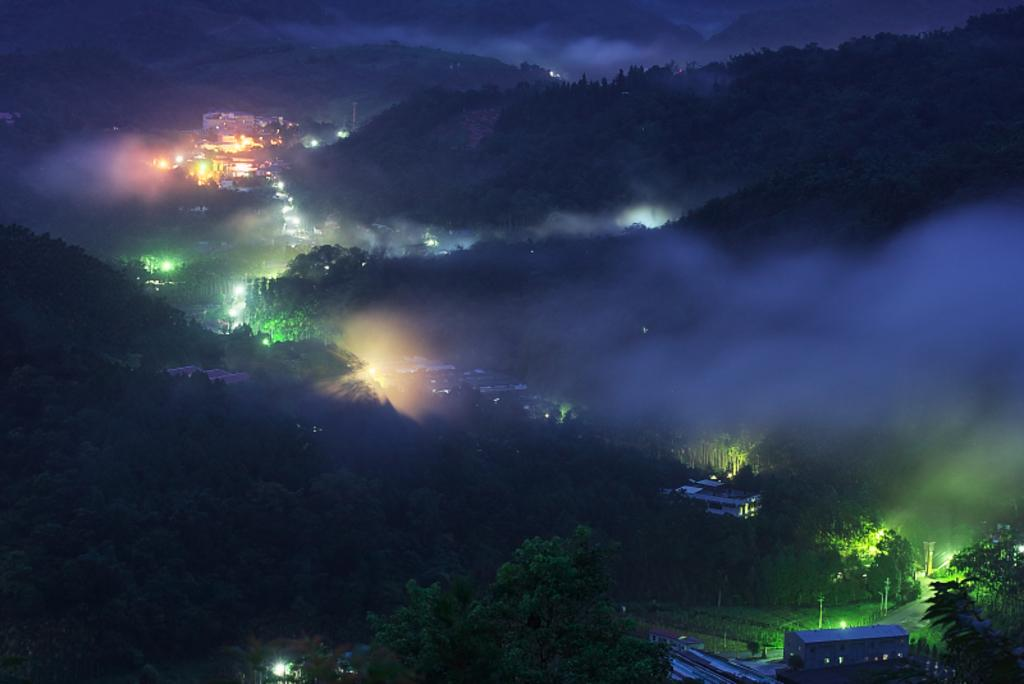What type of natural feature can be seen in the image? There is a group of trees in the image. What type of man-made structures are present in the image? There are buildings in the image. What type of vertical structures can be seen in the image? There are poles in the image. What type of illumination is present in the image? There are lights in the image. What type of geographical feature can be seen in the image? There are hills in the image. What is visible in the sky in the image? The sky is visible in the image and appears cloudy. Where is the crate located in the image? There is no crate present in the image. Can you tell me the name of the uncle in the image? There is no person or family member mentioned in the image. 